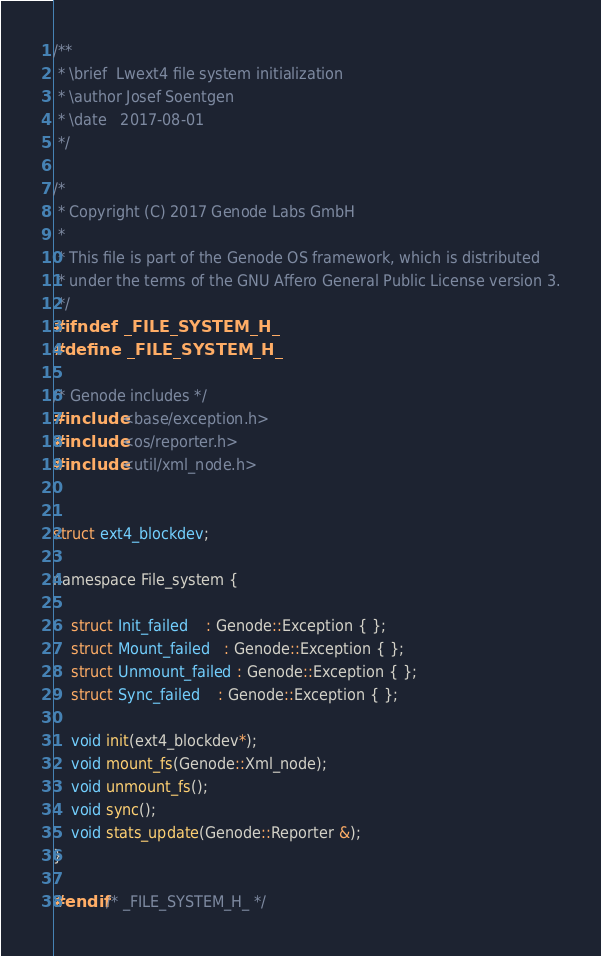Convert code to text. <code><loc_0><loc_0><loc_500><loc_500><_C_>/**
 * \brief  Lwext4 file system initialization
 * \author Josef Soentgen
 * \date   2017-08-01
 */

/*
 * Copyright (C) 2017 Genode Labs GmbH
 *
 * This file is part of the Genode OS framework, which is distributed
 * under the terms of the GNU Affero General Public License version 3.
 */
#ifndef _FILE_SYSTEM_H_
#define _FILE_SYSTEM_H_

/* Genode includes */
#include <base/exception.h>
#include <os/reporter.h>
#include <util/xml_node.h>


struct ext4_blockdev;

namespace File_system {

	struct Init_failed    : Genode::Exception { };
	struct Mount_failed   : Genode::Exception { };
	struct Unmount_failed : Genode::Exception { };
	struct Sync_failed    : Genode::Exception { };

	void init(ext4_blockdev*);
	void mount_fs(Genode::Xml_node);
	void unmount_fs();
	void sync();
	void stats_update(Genode::Reporter &);
}

#endif /* _FILE_SYSTEM_H_ */
</code> 